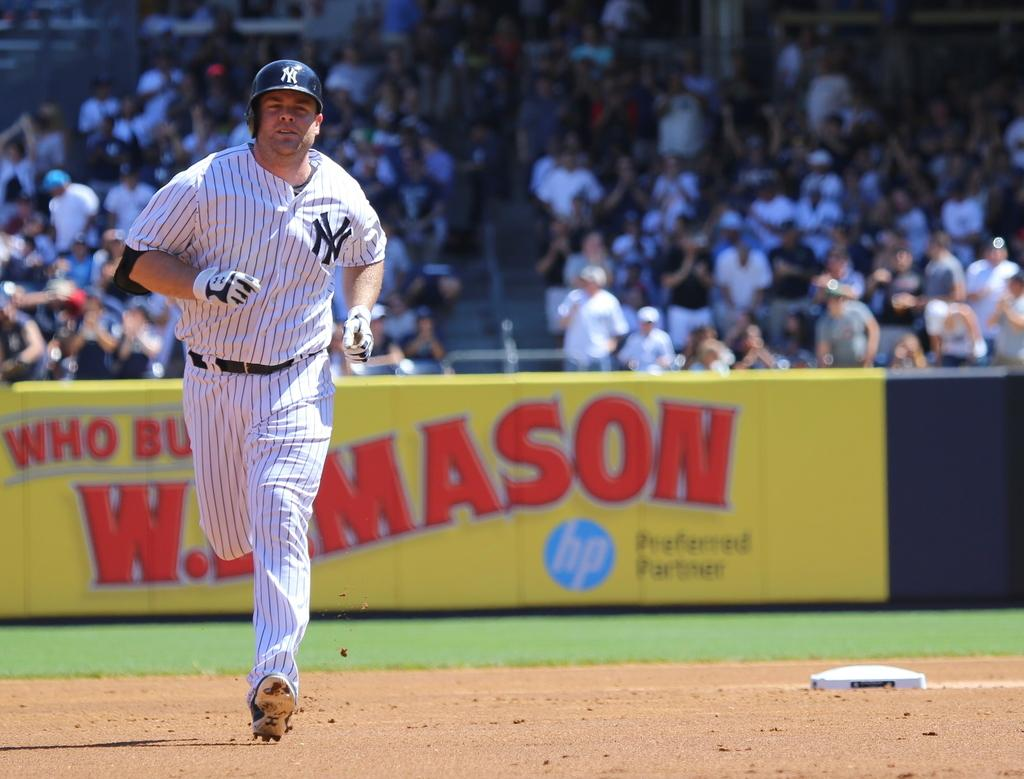<image>
Summarize the visual content of the image. The printing company advertised behind the player is HP. 